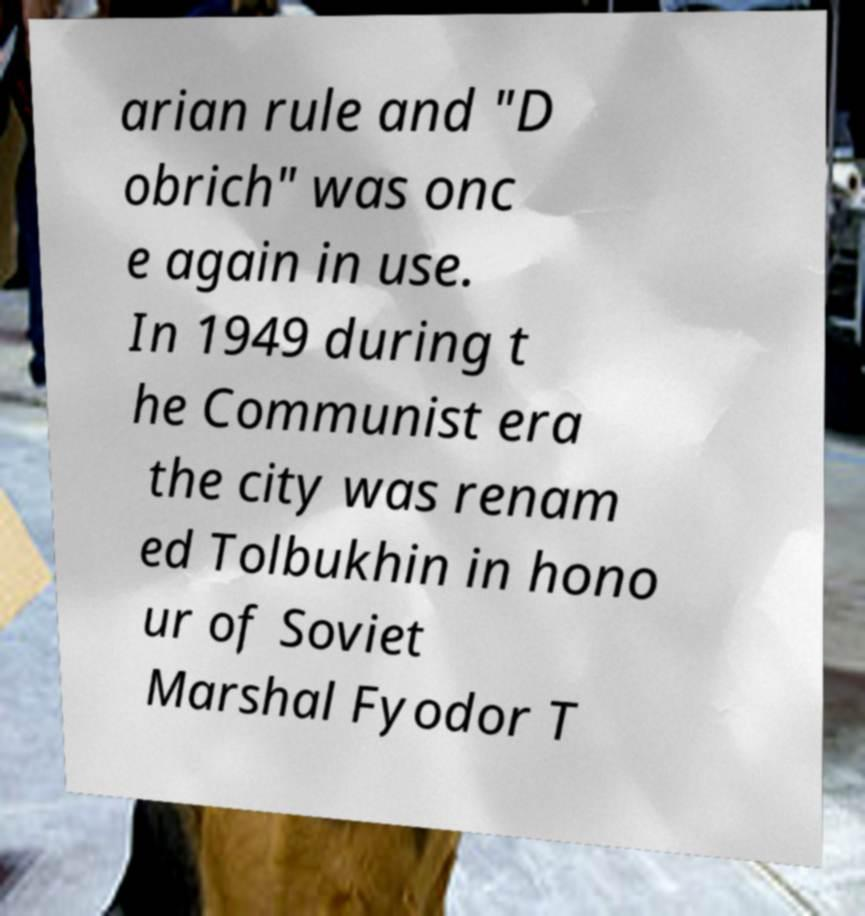Can you read and provide the text displayed in the image?This photo seems to have some interesting text. Can you extract and type it out for me? arian rule and "D obrich" was onc e again in use. In 1949 during t he Communist era the city was renam ed Tolbukhin in hono ur of Soviet Marshal Fyodor T 